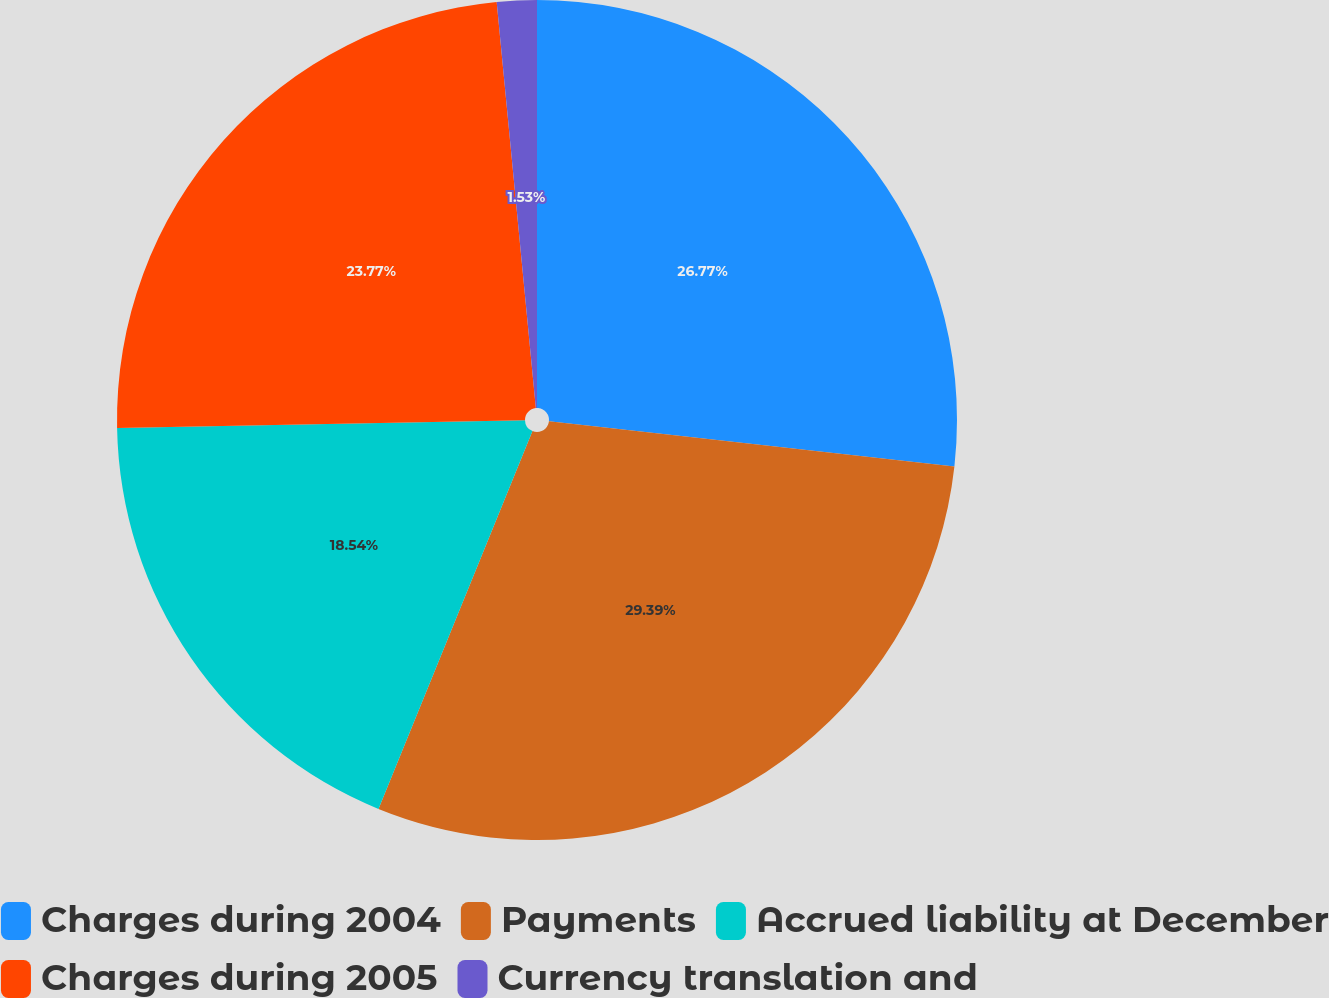<chart> <loc_0><loc_0><loc_500><loc_500><pie_chart><fcel>Charges during 2004<fcel>Payments<fcel>Accrued liability at December<fcel>Charges during 2005<fcel>Currency translation and<nl><fcel>26.77%<fcel>29.39%<fcel>18.54%<fcel>23.77%<fcel>1.53%<nl></chart> 